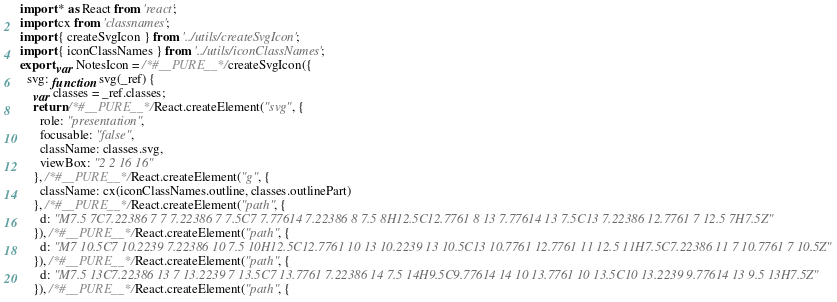Convert code to text. <code><loc_0><loc_0><loc_500><loc_500><_JavaScript_>import * as React from 'react';
import cx from 'classnames';
import { createSvgIcon } from '../utils/createSvgIcon';
import { iconClassNames } from '../utils/iconClassNames';
export var NotesIcon = /*#__PURE__*/createSvgIcon({
  svg: function svg(_ref) {
    var classes = _ref.classes;
    return /*#__PURE__*/React.createElement("svg", {
      role: "presentation",
      focusable: "false",
      className: classes.svg,
      viewBox: "2 2 16 16"
    }, /*#__PURE__*/React.createElement("g", {
      className: cx(iconClassNames.outline, classes.outlinePart)
    }, /*#__PURE__*/React.createElement("path", {
      d: "M7.5 7C7.22386 7 7 7.22386 7 7.5C7 7.77614 7.22386 8 7.5 8H12.5C12.7761 8 13 7.77614 13 7.5C13 7.22386 12.7761 7 12.5 7H7.5Z"
    }), /*#__PURE__*/React.createElement("path", {
      d: "M7 10.5C7 10.2239 7.22386 10 7.5 10H12.5C12.7761 10 13 10.2239 13 10.5C13 10.7761 12.7761 11 12.5 11H7.5C7.22386 11 7 10.7761 7 10.5Z"
    }), /*#__PURE__*/React.createElement("path", {
      d: "M7.5 13C7.22386 13 7 13.2239 7 13.5C7 13.7761 7.22386 14 7.5 14H9.5C9.77614 14 10 13.7761 10 13.5C10 13.2239 9.77614 13 9.5 13H7.5Z"
    }), /*#__PURE__*/React.createElement("path", {</code> 